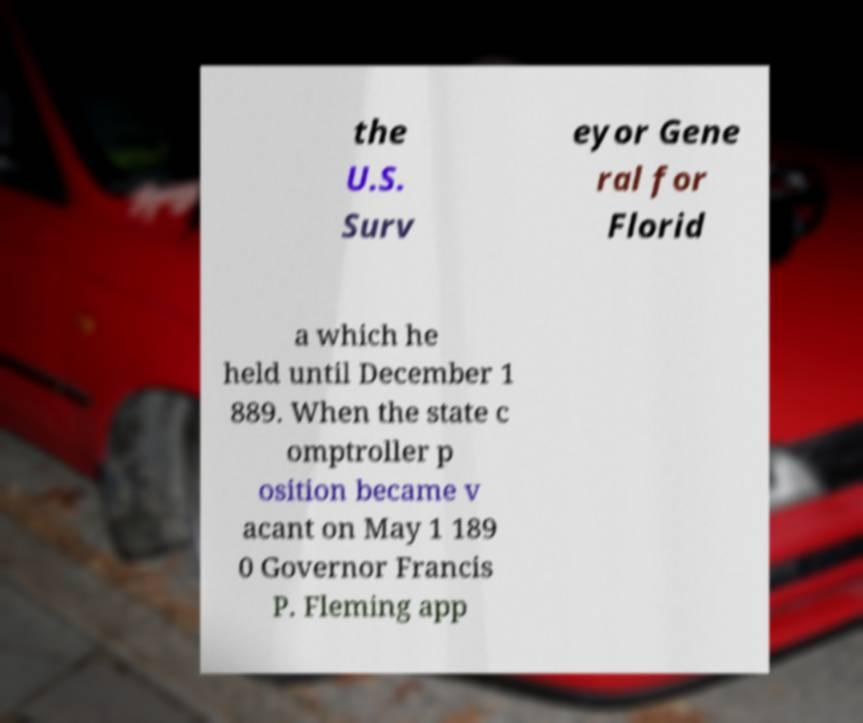Please read and relay the text visible in this image. What does it say? the U.S. Surv eyor Gene ral for Florid a which he held until December 1 889. When the state c omptroller p osition became v acant on May 1 189 0 Governor Francis P. Fleming app 